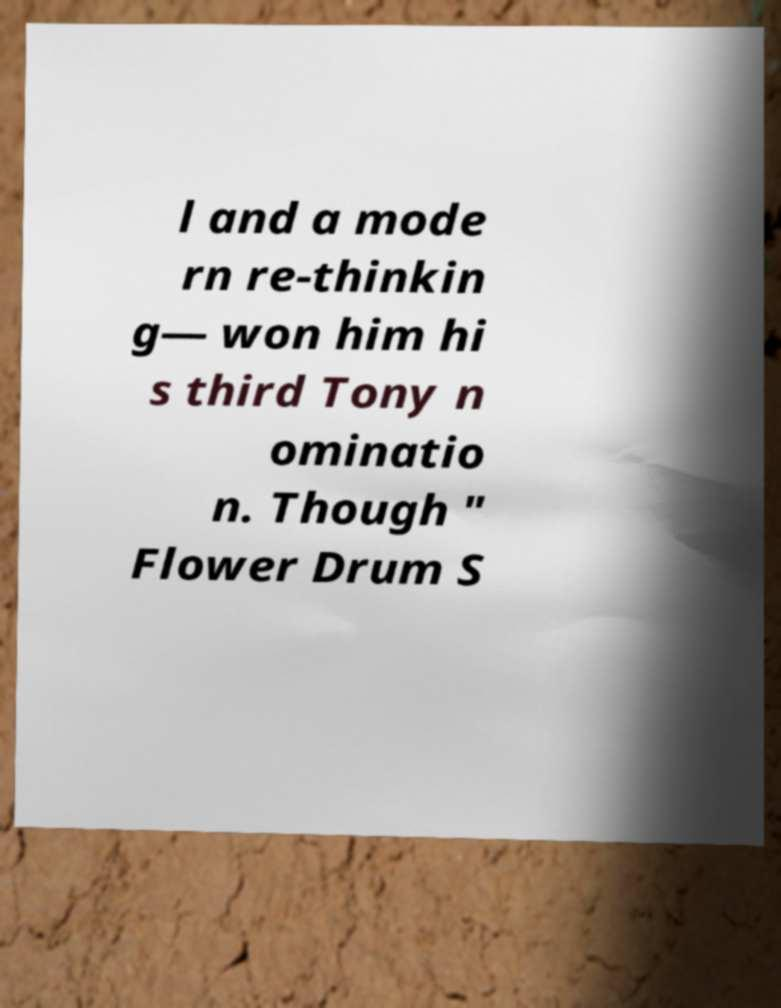Could you assist in decoding the text presented in this image and type it out clearly? l and a mode rn re-thinkin g— won him hi s third Tony n ominatio n. Though " Flower Drum S 